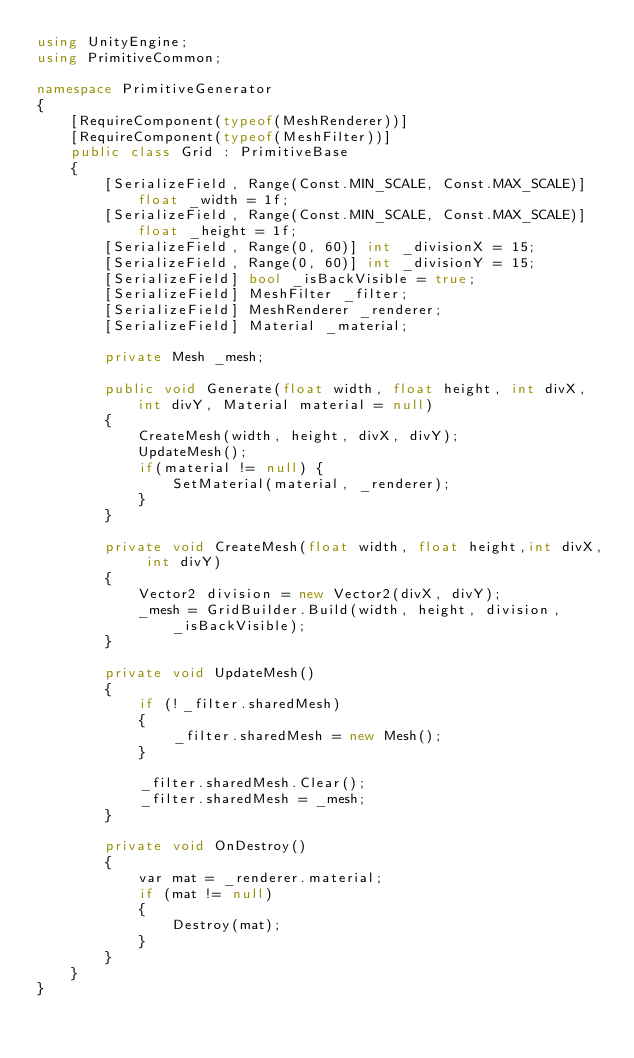Convert code to text. <code><loc_0><loc_0><loc_500><loc_500><_C#_>using UnityEngine;
using PrimitiveCommon;

namespace PrimitiveGenerator
{
    [RequireComponent(typeof(MeshRenderer))]
    [RequireComponent(typeof(MeshFilter))]
    public class Grid : PrimitiveBase
    {
        [SerializeField, Range(Const.MIN_SCALE, Const.MAX_SCALE)] float _width = 1f;
        [SerializeField, Range(Const.MIN_SCALE, Const.MAX_SCALE)] float _height = 1f;
        [SerializeField, Range(0, 60)] int _divisionX = 15;
        [SerializeField, Range(0, 60)] int _divisionY = 15;
        [SerializeField] bool _isBackVisible = true;
        [SerializeField] MeshFilter _filter;
        [SerializeField] MeshRenderer _renderer;
        [SerializeField] Material _material;

        private Mesh _mesh;

        public void Generate(float width, float height, int divX, int divY, Material material = null)
        {
            CreateMesh(width, height, divX, divY);
            UpdateMesh();
            if(material != null) {
                SetMaterial(material, _renderer);
            }
        }

        private void CreateMesh(float width, float height,int divX, int divY)
        {
            Vector2 division = new Vector2(divX, divY);
            _mesh = GridBuilder.Build(width, height, division, _isBackVisible);
        }

        private void UpdateMesh()
        {
            if (!_filter.sharedMesh)
            {
                _filter.sharedMesh = new Mesh();
            }

            _filter.sharedMesh.Clear();
            _filter.sharedMesh = _mesh;
        }

        private void OnDestroy()
        {
            var mat = _renderer.material;
            if (mat != null)
            {
                Destroy(mat);
            }
        }
    }
}
</code> 